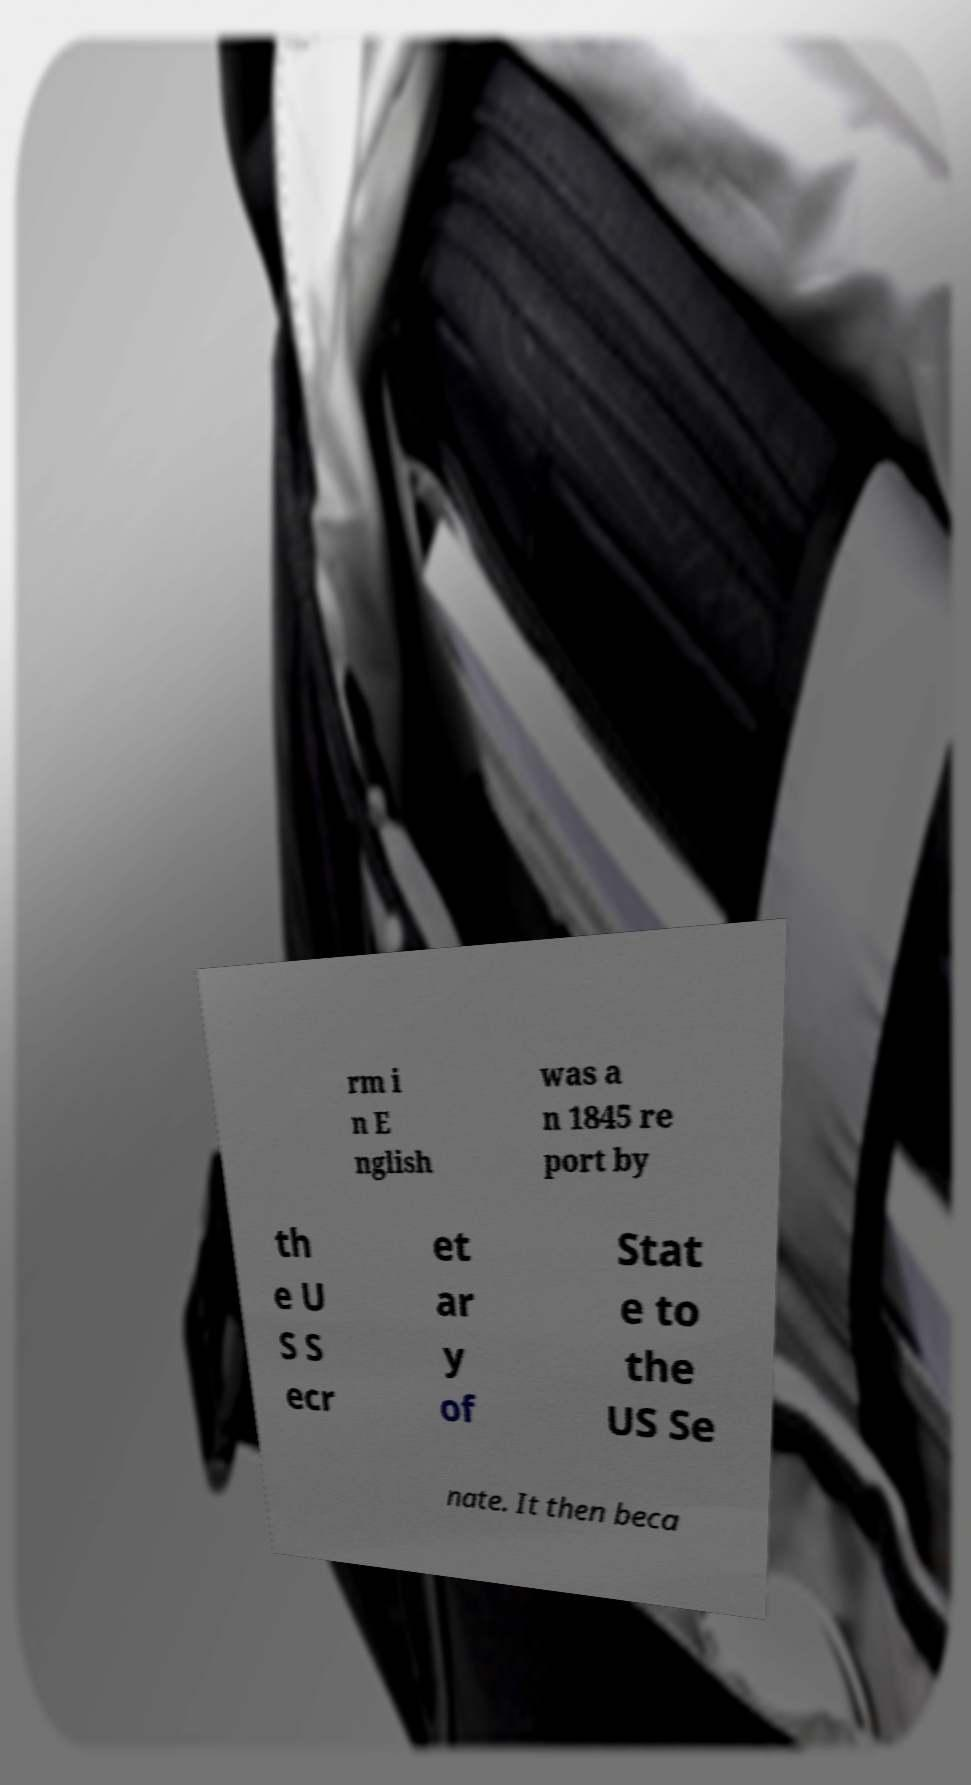For documentation purposes, I need the text within this image transcribed. Could you provide that? rm i n E nglish was a n 1845 re port by th e U S S ecr et ar y of Stat e to the US Se nate. It then beca 